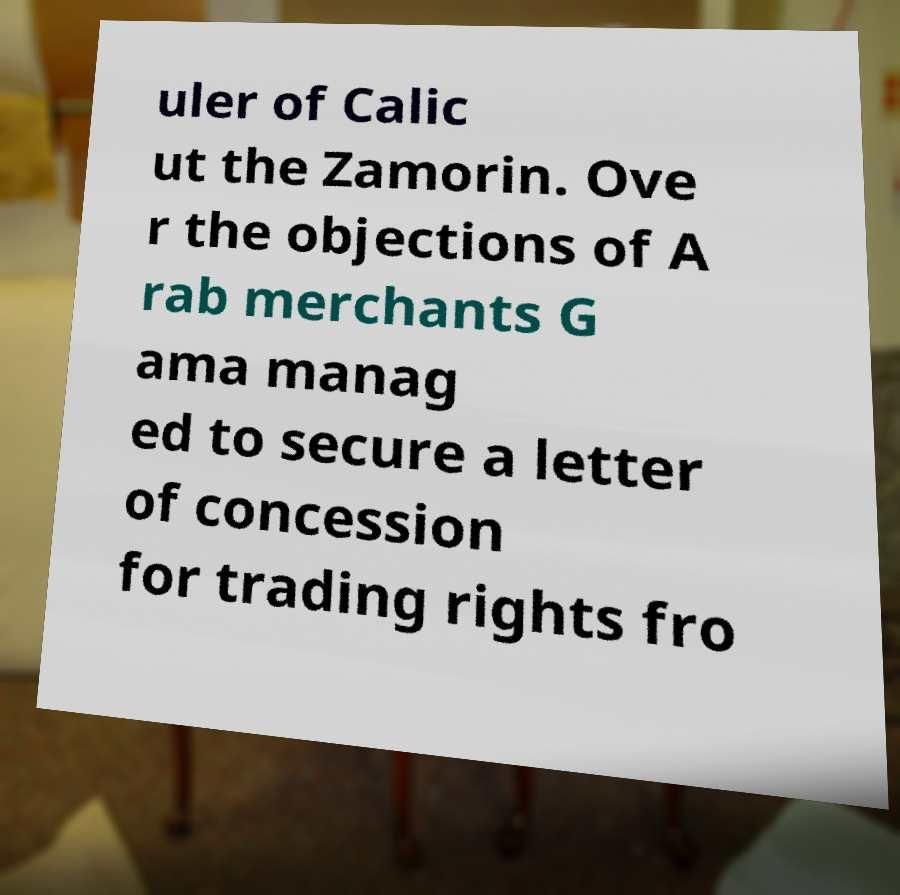What messages or text are displayed in this image? I need them in a readable, typed format. uler of Calic ut the Zamorin. Ove r the objections of A rab merchants G ama manag ed to secure a letter of concession for trading rights fro 